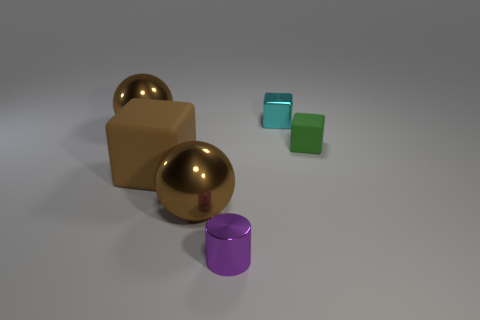Are there any large brown objects that have the same shape as the small purple thing?
Offer a terse response. No. How many objects are big objects or metal cylinders in front of the tiny green matte thing?
Your response must be concise. 4. What number of other objects are there of the same material as the large brown block?
Ensure brevity in your answer.  1. How many objects are cyan metallic things or gray spheres?
Make the answer very short. 1. Is the number of brown metallic things that are in front of the metallic cylinder greater than the number of large cubes right of the small rubber object?
Give a very brief answer. No. Is the color of the tiny metallic thing that is to the right of the tiny purple object the same as the matte cube that is on the right side of the cyan block?
Make the answer very short. No. There is a shiny thing left of the shiny sphere that is in front of the brown rubber object behind the purple shiny thing; what is its size?
Offer a very short reply. Large. There is another large thing that is the same shape as the green thing; what color is it?
Provide a succinct answer. Brown. Are there more purple things left of the tiny cylinder than brown objects?
Ensure brevity in your answer.  No. There is a large brown matte thing; is its shape the same as the thing right of the cyan block?
Offer a terse response. Yes. 